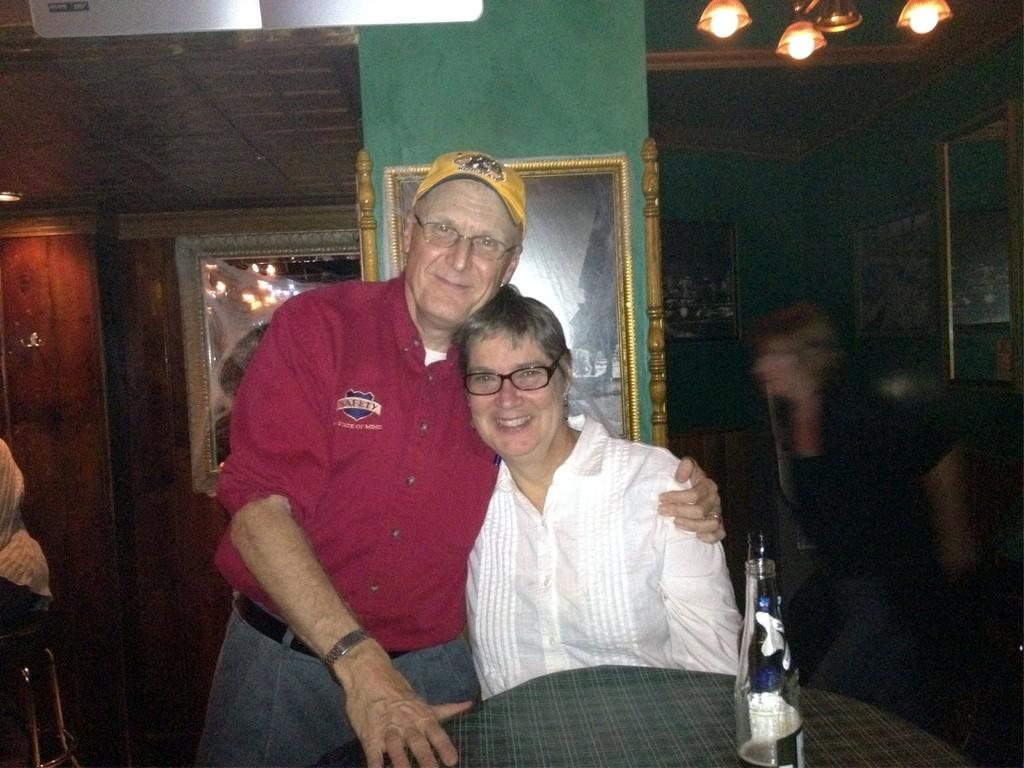Who is the main subject in the image? There is an old man in the image. What is the old man doing in the image? The old man is holding an old woman. What object can be seen on a table in the image? There is a bottle on a table in the image. What is hanging on the wall in the image? There is a photo frame on the wall in the image. What type of insect can be seen performing on the stage in the image? There is no insect or stage present in the image. What answer is the old man giving to the question in the image? There is no question or answer being given in the image; the old man is simply holding an old woman. 